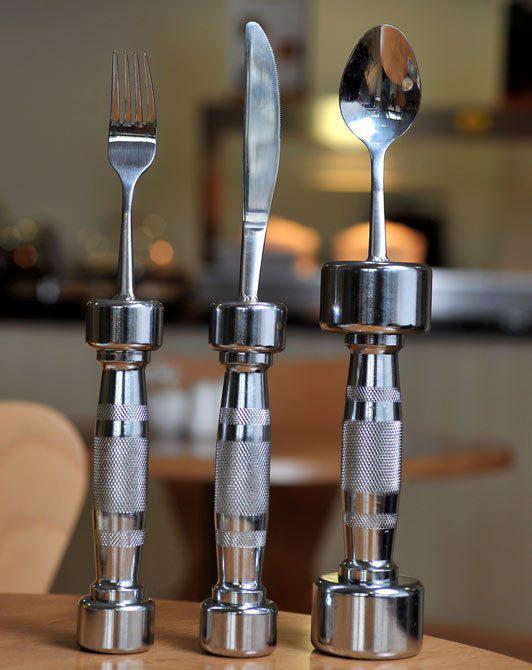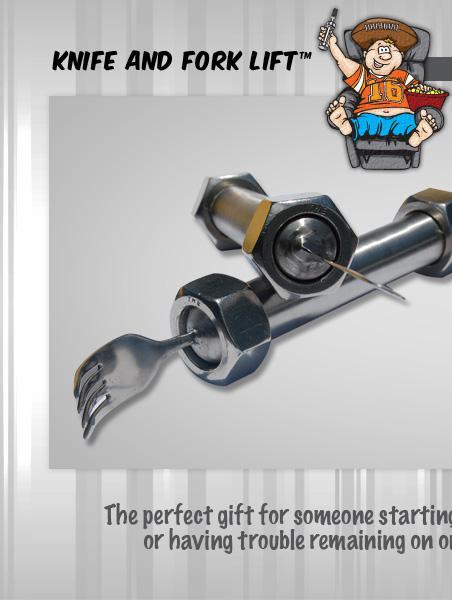The first image is the image on the left, the second image is the image on the right. For the images displayed, is the sentence "One image shows a matched set of knife, fork, and spoon utensils standing on end." factually correct? Answer yes or no. Yes. The first image is the image on the left, the second image is the image on the right. For the images displayed, is the sentence "Left image shows three utensils with barbell-shaped handles." factually correct? Answer yes or no. Yes. 